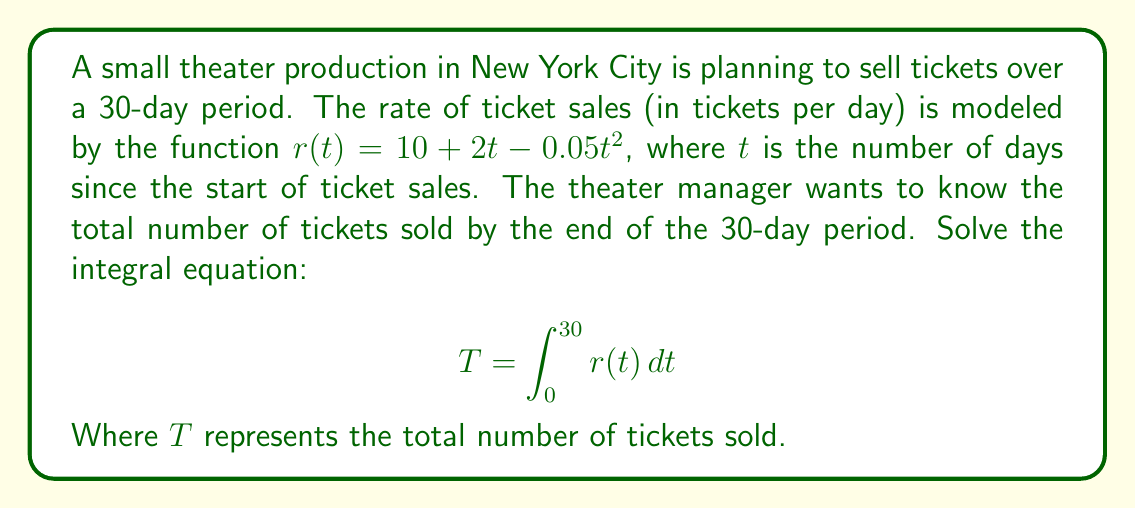What is the answer to this math problem? Let's solve this integral equation step-by-step:

1) We need to integrate $r(t) = 10 + 2t - 0.05t^2$ from 0 to 30.

2) Set up the integral:
   $$T = \int_0^{30} (10 + 2t - 0.05t^2) dt$$

3) Integrate each term:
   $$T = [10t + t^2 - \frac{0.05}{3}t^3]_0^{30}$$

4) Evaluate the antiderivative at the upper and lower bounds:
   $$T = (300 + 900 - 450) - (0 + 0 - 0)$$

5) Simplify:
   $$T = 750$$

Therefore, the total number of tickets sold over the 30-day period is 750.
Answer: 750 tickets 